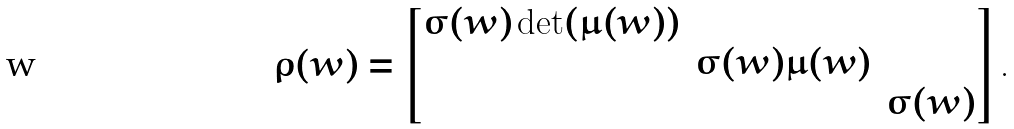<formula> <loc_0><loc_0><loc_500><loc_500>\rho ( w ) = \begin{bmatrix} \sigma ( w ) \det ( \mu ( w ) ) & & \\ & \sigma ( w ) \mu ( w ) \\ & & \sigma ( w ) \end{bmatrix} .</formula> 